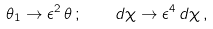Convert formula to latex. <formula><loc_0><loc_0><loc_500><loc_500>\theta _ { 1 } \to \epsilon ^ { 2 } \, \theta \, ; \quad d \chi \to \epsilon ^ { 4 } \, d \chi \, ,</formula> 